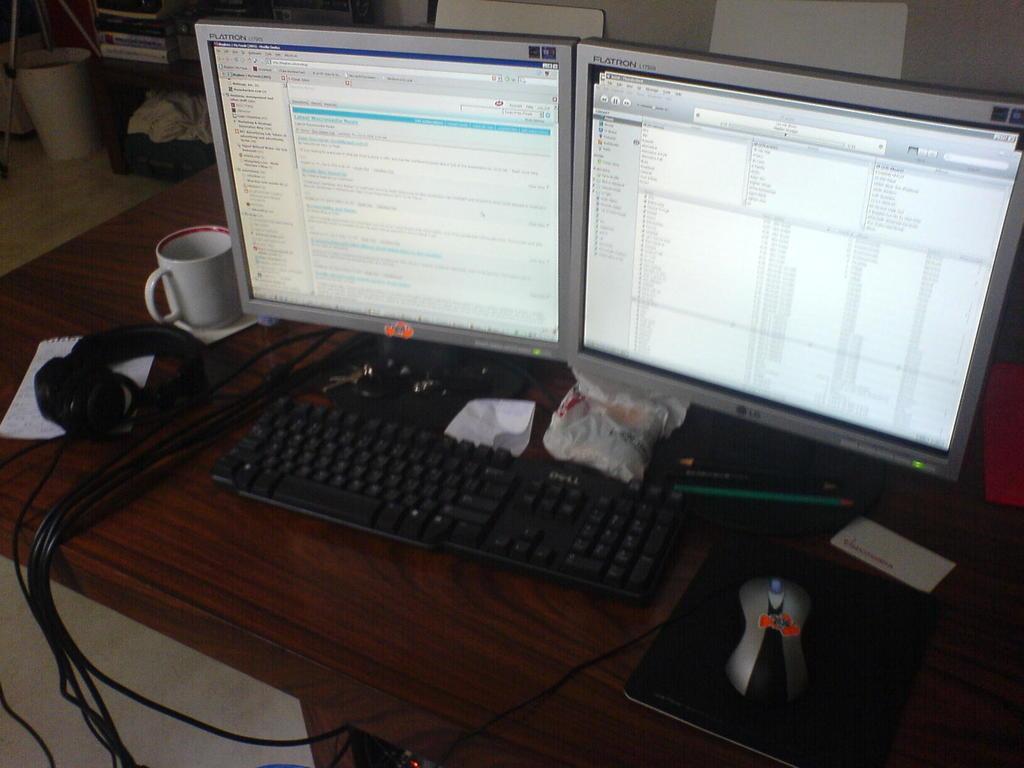Can you describe this image briefly? This image is taken inside a room. In this image there is a table and on top of that there is a headset, cup, two monitor screens, keyboard, mouse pad, mouse, paper and pen on it. In the bottom of the image there is a floor. In the background there is a wall, bookshelf with books in it. 